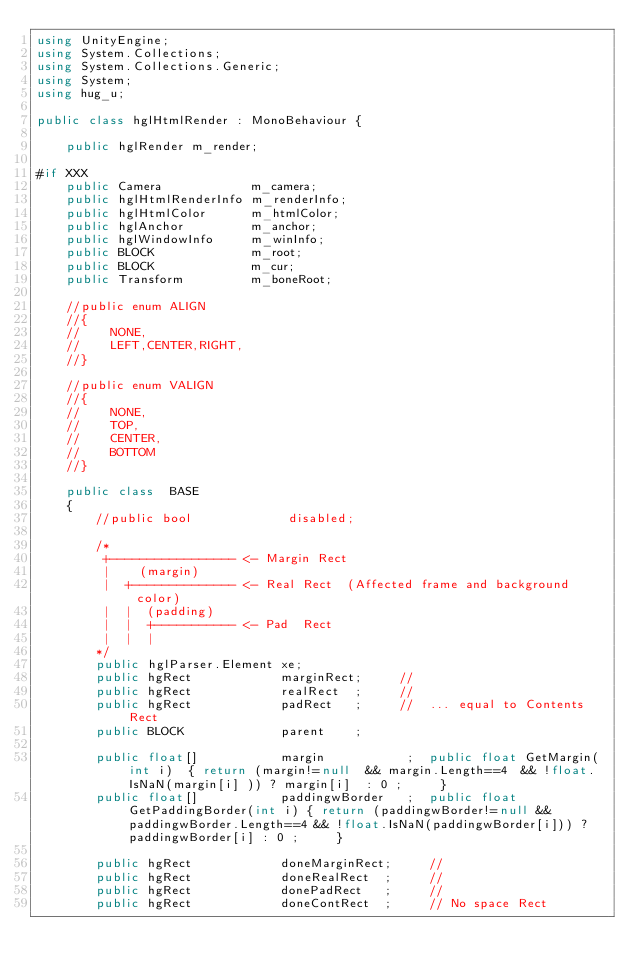Convert code to text. <code><loc_0><loc_0><loc_500><loc_500><_C#_>using UnityEngine;
using System.Collections;
using System.Collections.Generic;
using System;
using hug_u;

public class hglHtmlRender : MonoBehaviour {

    public hglRender m_render;

#if XXX
    public Camera            m_camera;
    public hglHtmlRenderInfo m_renderInfo;
    public hglHtmlColor      m_htmlColor;
    public hglAnchor         m_anchor;
    public hglWindowInfo     m_winInfo;
    public BLOCK             m_root;
    public BLOCK             m_cur;
    public Transform         m_boneRoot;

    //public enum ALIGN
    //{
    //    NONE,
    //    LEFT,CENTER,RIGHT,
    //}

    //public enum VALIGN
    //{
    //    NONE,
    //    TOP,
    //    CENTER,
    //    BOTTOM
    //}

    public class  BASE
    {
        //public bool             disabled;

        /*
         +----------------- <- Margin Rect
         |    (margin)
         |  +-------------- <- Real Rect  (Affected frame and background color)
         |  |  (padding)  
         |  |  +----------- <- Pad  Rect  
         |  |  |               
        */
        public hglParser.Element xe;
        public hgRect            marginRect;     //  
        public hgRect            realRect  ;     //   
        public hgRect            padRect   ;     //  ... equal to Contents Rect
        public BLOCK             parent    ;

        public float[]           margin           ;  public float GetMargin(int i)  { return (margin!=null  && margin.Length==4  && !float.IsNaN(margin[i] )) ? margin[i]  : 0 ;     }
        public float[]           paddingwBorder   ;  public float GetPaddingBorder(int i) { return (paddingwBorder!=null && paddingwBorder.Length==4 && !float.IsNaN(paddingwBorder[i])) ? paddingwBorder[i] : 0 ;     }

        public hgRect            doneMarginRect;     //
        public hgRect            doneRealRect  ;     //
        public hgRect            donePadRect   ;     //
        public hgRect            doneContRect  ;     // No space Rect
</code> 